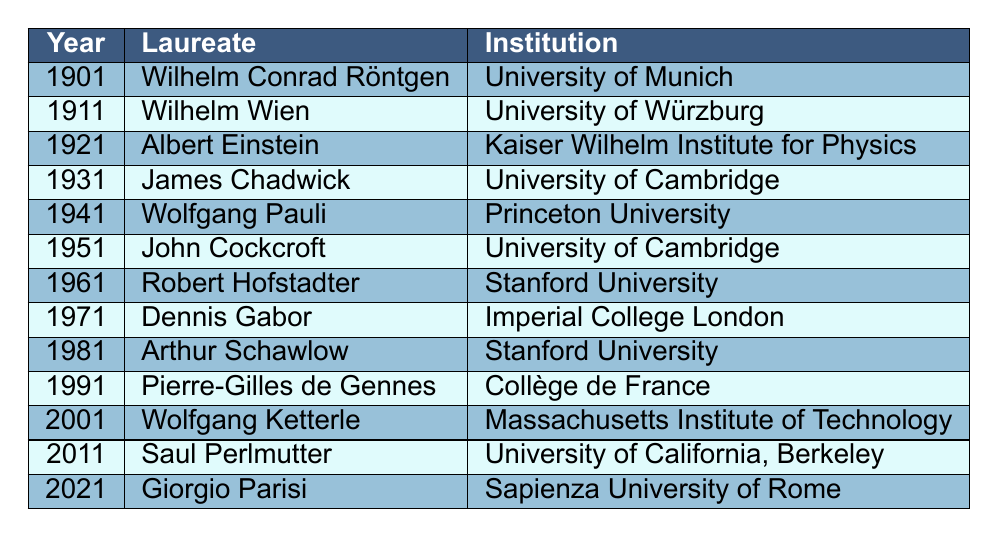What institution awarded the Nobel Prize in Physics to Albert Einstein? The table lists Albert Einstein alongside the year 1921 and specifies the institution as the Kaiser Wilhelm Institute for Physics.
Answer: Kaiser Wilhelm Institute for Physics Which laureate won the Nobel Prize in Physics in 1951? By looking at the row for the year 1951, it is clear that John Cockcroft is the laureate listed for that year.
Answer: John Cockcroft How many laureates are associated with Stanford University? The table shows two instances where Stanford University is listed: for Robert Hofstadter in 1961 and Arthur Schawlow in 1981. Therefore, there are two laureates associated with this institution.
Answer: 2 Who is the earliest Nobel Prize winner listed in the table? The first entry in the table is for the year 1901, and the laureate is Wilhelm Conrad Röntgen, making him the earliest winner presented.
Answer: Wilhelm Conrad Röntgen Do any laureates associated with the University of Cambridge won the prize after 1941? The table includes John Cockcroft associated with the University of Cambridge in 1951. Thus, there is a post-1941 laureate from this institution.
Answer: Yes How many years apart were the awards to Wolfgang Pauli and Pierre-Gilles de Gennes? Wolfgang Pauli won in 1941 and Pierre-Gilles de Gennes won in 1991. The difference is 1991 - 1941 = 50 years.
Answer: 50 years Which institution has the highest number of laureates according to this table? The table shows that both Stanford University and the University of Cambridge have two laureates each, while others only have one. Therefore, these two institutions share the highest count.
Answer: Two institutions (Stanford University and University of Cambridge) What is the average time span between Nobel Prize winners listed in the table? The years of the prize winners are from 1901 to 2021, which spans 121 years and includes 13 winners. Thus, the average span is 121 years / 12 intervals = approximately 10.08 years.
Answer: Approximately 10 years Was there a prize winner that was affiliated with Imperial College London? From the table, it is clear that Dennis Gabor won in 1971 and is affiliated with Imperial College London. Therefore, yes, there was a winner from that institution.
Answer: Yes Who won the Nobel Prize in Physics most recently according to the table? The last year listed is 2021, where Giorgio Parisi is named as the winner, making him the most recent laureate.
Answer: Giorgio Parisi 